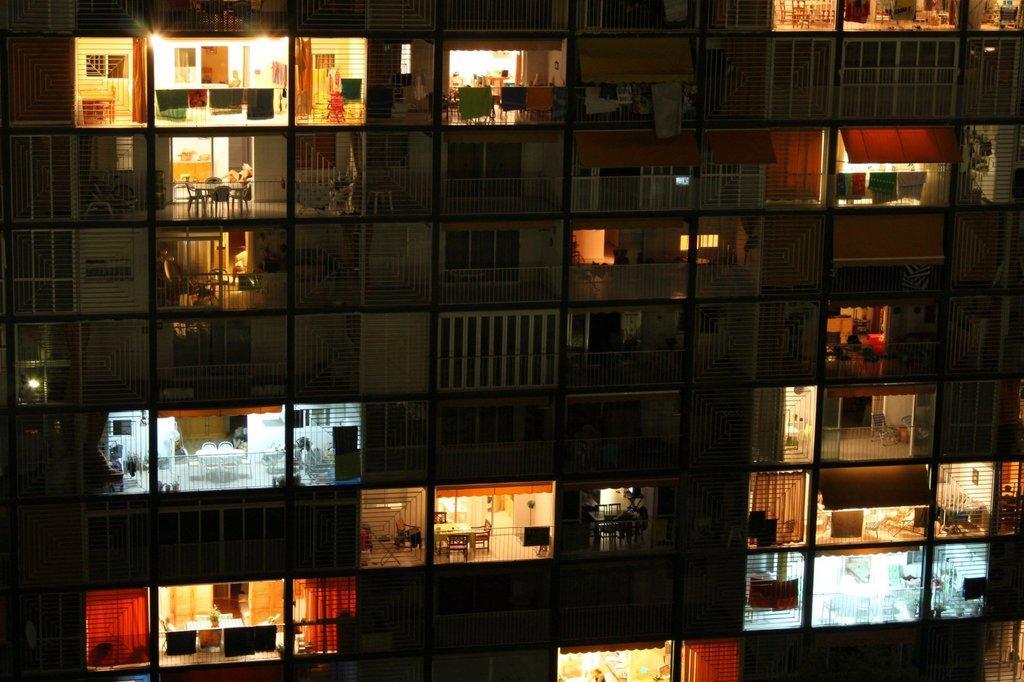In one or two sentences, can you explain what this image depicts? In this image, we can see a building. We can see balconies, clothes, lights, chairs, walls, railings, tables and some objects. 